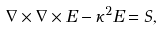Convert formula to latex. <formula><loc_0><loc_0><loc_500><loc_500>\nabla \times \nabla \times { E } - \kappa ^ { 2 } { E } = { S } ,</formula> 